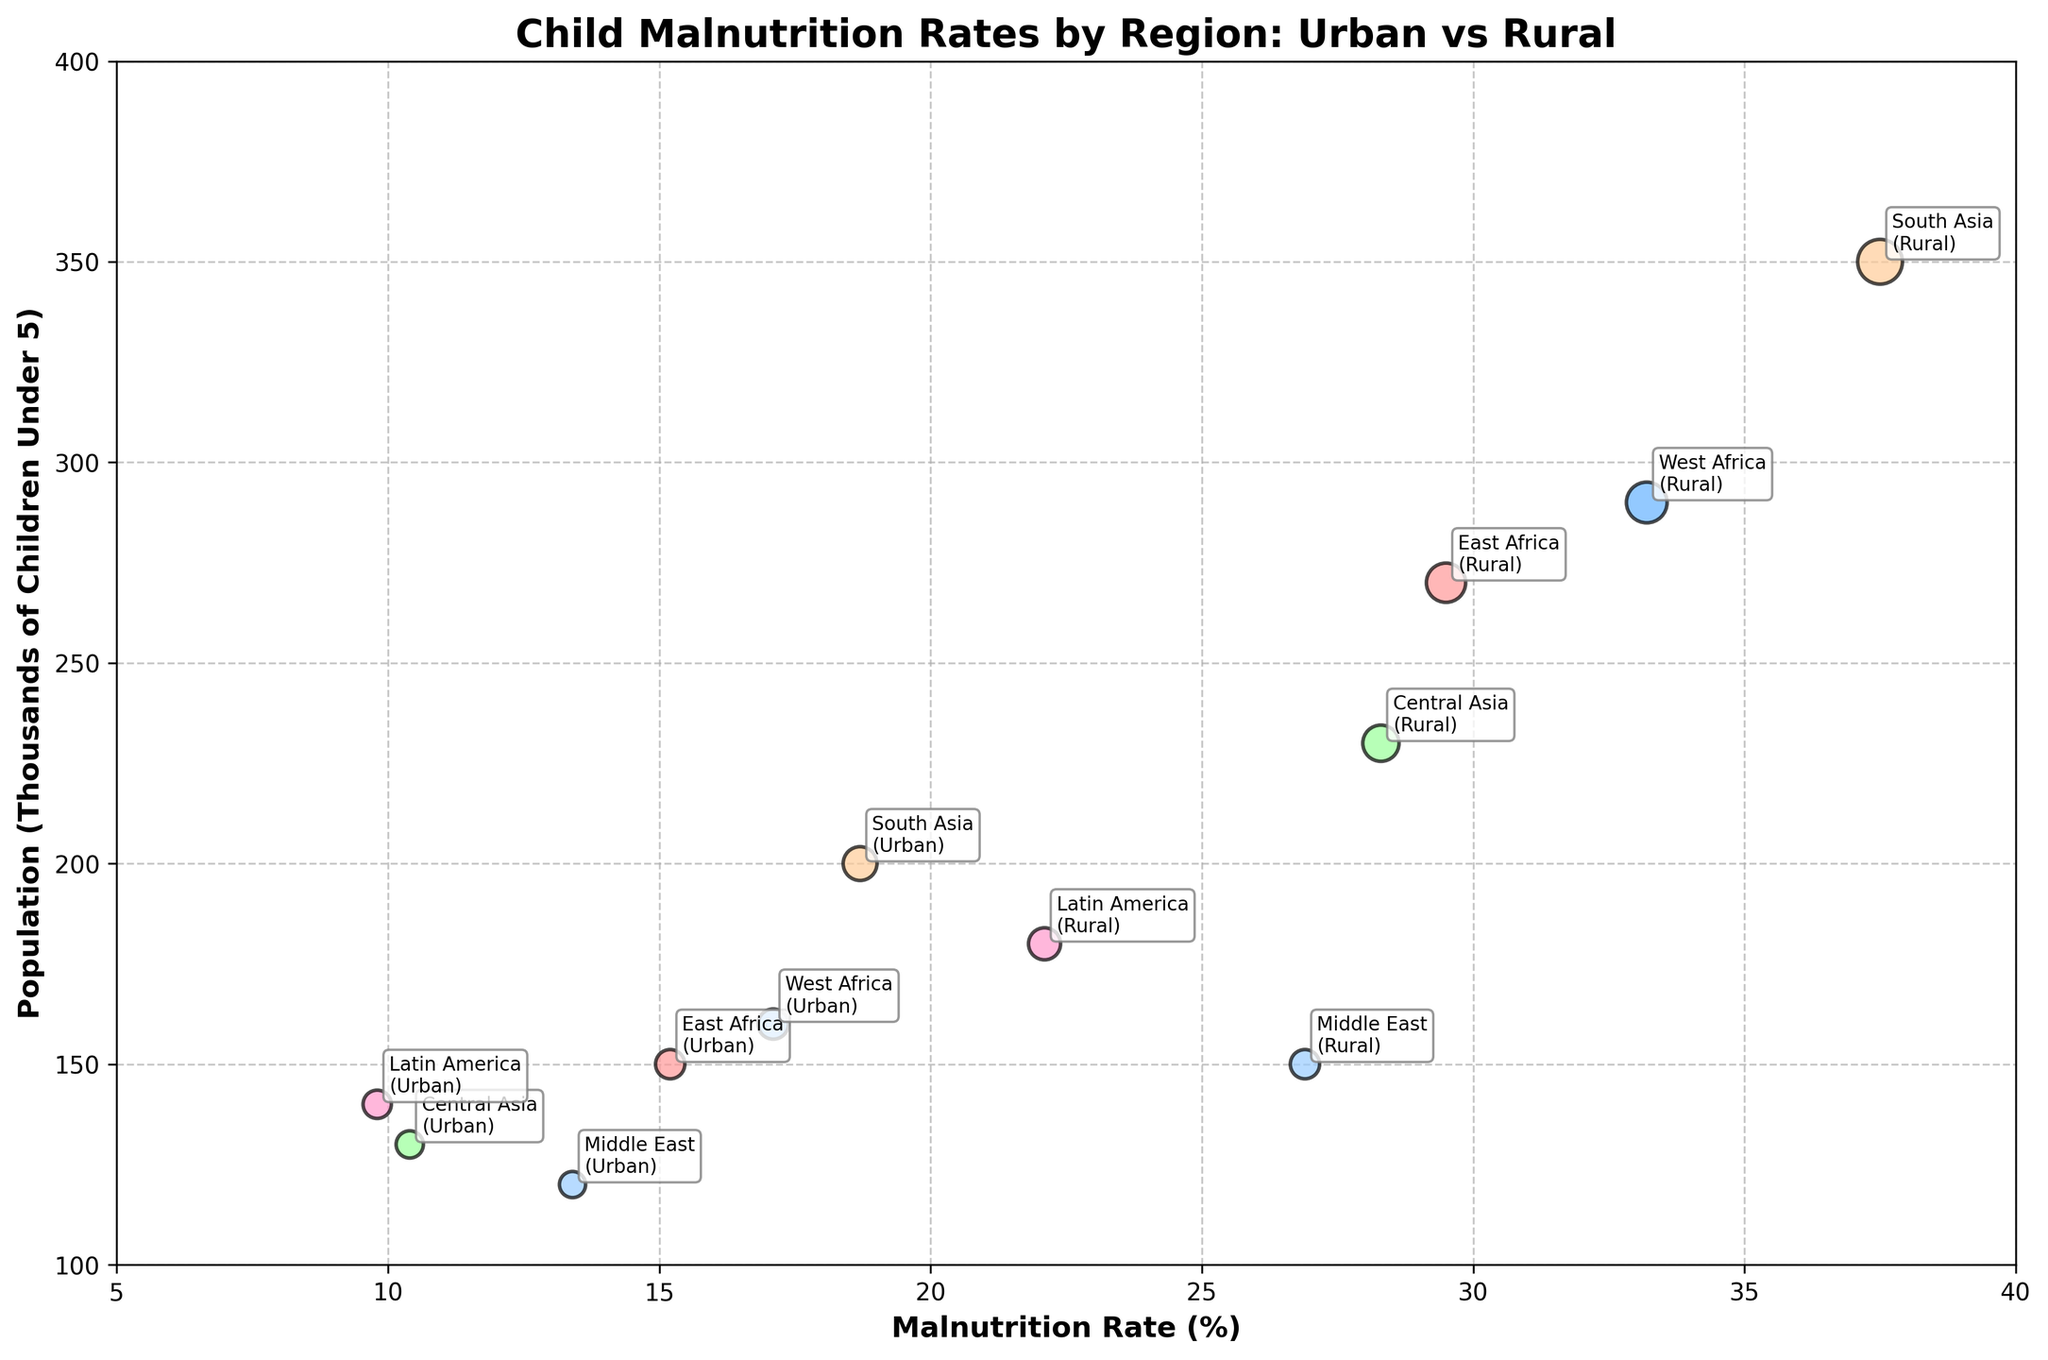What's the title of the figure? The title of the figure can be found at the top of the plot, usually large and bold to catch attention.
Answer: Child Malnutrition Rates by Region: Urban vs Rural How many regions are represented in the chart? The chart uses different colors for each region, and inspecting the labeled bubbles shows the number of unique regions.
Answer: 6 What is the malnutrition rate in rural East Africa? By locating the East Africa rural bubble and reading the corresponding malnutrition rate on the x-axis, we can determine the rate.
Answer: 29.5% Which region has the highest malnutrition rate in urban areas? By comparing the malnutrition rates of all urban areas, we can identify the highest value.
Answer: South Asia Which has a larger population of children under 5: rural Latin America or urban South Asia? We compare the size of the bubbles (representing population) for rural Latin America and urban South Asia. The larger bubble indicates the region with the larger population.
Answer: Urban South Asia What's the difference in malnutrition rates between urban and rural West Africa? Subtract the malnutrition rate of urban West Africa from rural West Africa.
Answer: 16.1% For which region is the population of children under 5 greater in urban areas than in rural areas? Comparing the sizes of both urban and rural bubbles for each region visually, we find the appropriate regions where the urban populations are larger than rural populations.
Answer: No region What's the average malnutrition rate for the rural areas shown? Add up all the malnutrition rates for rural areas and divide by the number of rural regions. (29.5 + 33.2 + 28.3 + 37.5 + 22.1 + 26.9) / 6
Answer: 29.58% Which region has the smallest malnutrition rate overall? Look at both urban and rural areas in each region to find the smallest malnutrition rate.
Answer: Latin America (Urban) Is there a region where the urban and rural malnutrition rates are roughly the same? Compare the malnutrition rates between urban and rural areas for each region to spot any similarities.
Answer: No 